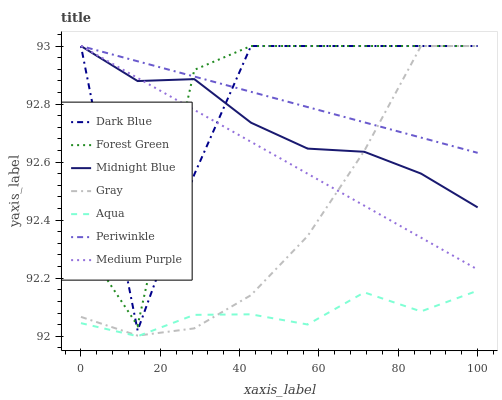Does Aqua have the minimum area under the curve?
Answer yes or no. Yes. Does Periwinkle have the maximum area under the curve?
Answer yes or no. Yes. Does Midnight Blue have the minimum area under the curve?
Answer yes or no. No. Does Midnight Blue have the maximum area under the curve?
Answer yes or no. No. Is Medium Purple the smoothest?
Answer yes or no. Yes. Is Forest Green the roughest?
Answer yes or no. Yes. Is Midnight Blue the smoothest?
Answer yes or no. No. Is Midnight Blue the roughest?
Answer yes or no. No. Does Midnight Blue have the lowest value?
Answer yes or no. No. Does Periwinkle have the highest value?
Answer yes or no. Yes. Does Aqua have the highest value?
Answer yes or no. No. Is Aqua less than Periwinkle?
Answer yes or no. Yes. Is Medium Purple greater than Aqua?
Answer yes or no. Yes. Does Gray intersect Dark Blue?
Answer yes or no. Yes. Is Gray less than Dark Blue?
Answer yes or no. No. Is Gray greater than Dark Blue?
Answer yes or no. No. Does Aqua intersect Periwinkle?
Answer yes or no. No. 